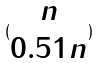Convert formula to latex. <formula><loc_0><loc_0><loc_500><loc_500>( \begin{matrix} n \\ 0 . 5 1 n \end{matrix} )</formula> 